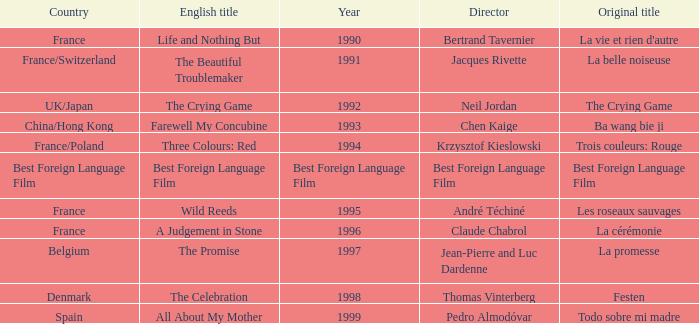What's the Original Title of the English title A Judgement in Stone? La cérémonie. 